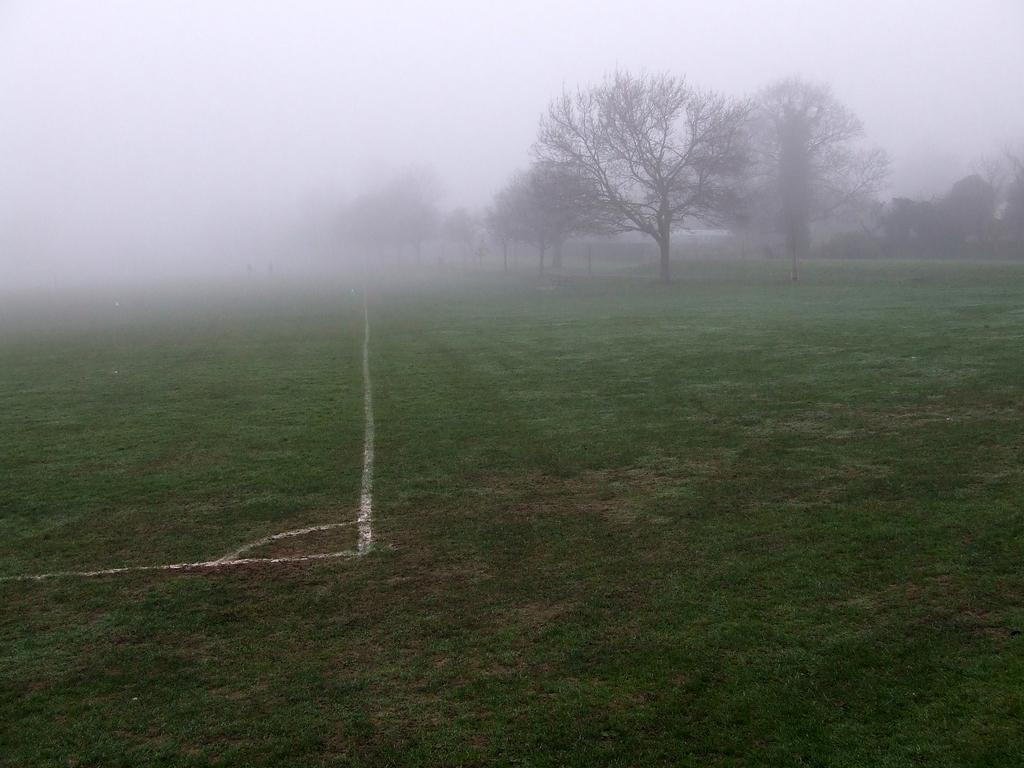Can you describe this image briefly? This image is taken outdoors. At the top of the image there is the sky. At the bottom of the image there is a ground with grass on it. In the middle of the image there are a few trees with stems and branches. 